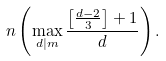Convert formula to latex. <formula><loc_0><loc_0><loc_500><loc_500>n \left ( \max _ { d | m } \frac { \left [ \frac { d - 2 } { 3 } \right ] + 1 } { d } \right ) .</formula> 